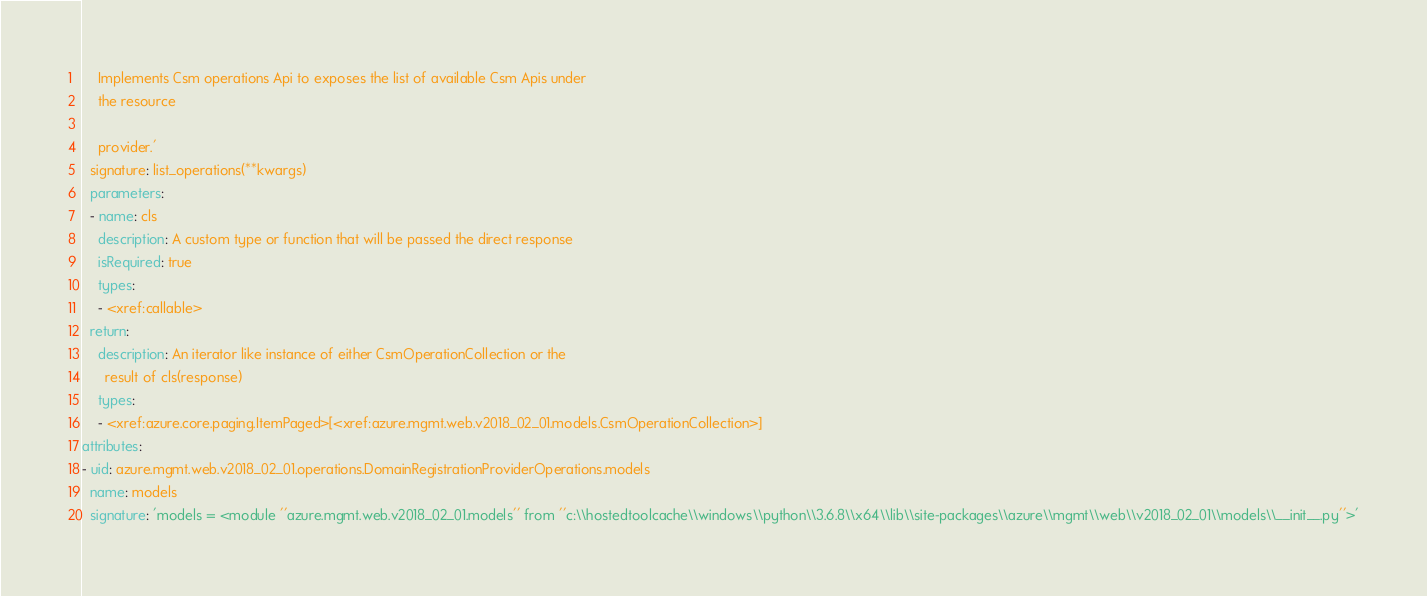<code> <loc_0><loc_0><loc_500><loc_500><_YAML_>

    Implements Csm operations Api to exposes the list of available Csm Apis under
    the resource

    provider.'
  signature: list_operations(**kwargs)
  parameters:
  - name: cls
    description: A custom type or function that will be passed the direct response
    isRequired: true
    types:
    - <xref:callable>
  return:
    description: An iterator like instance of either CsmOperationCollection or the
      result of cls(response)
    types:
    - <xref:azure.core.paging.ItemPaged>[<xref:azure.mgmt.web.v2018_02_01.models.CsmOperationCollection>]
attributes:
- uid: azure.mgmt.web.v2018_02_01.operations.DomainRegistrationProviderOperations.models
  name: models
  signature: 'models = <module ''azure.mgmt.web.v2018_02_01.models'' from ''c:\\hostedtoolcache\\windows\\python\\3.6.8\\x64\\lib\\site-packages\\azure\\mgmt\\web\\v2018_02_01\\models\\__init__.py''>'
</code> 